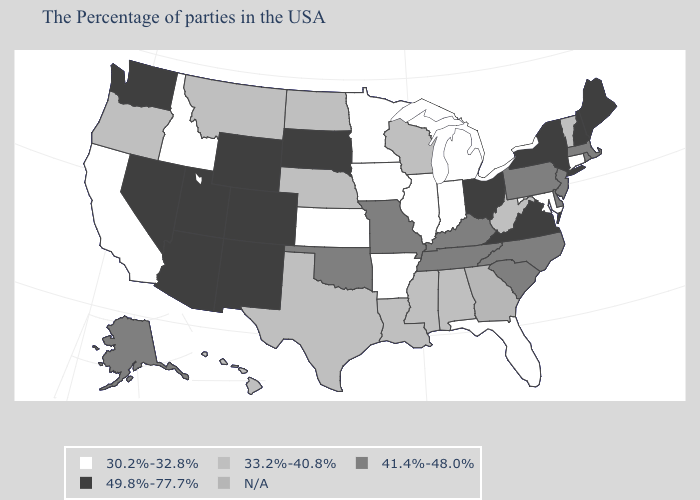What is the value of Pennsylvania?
Short answer required. 41.4%-48.0%. What is the highest value in the USA?
Concise answer only. 49.8%-77.7%. What is the value of Arkansas?
Be succinct. 30.2%-32.8%. Which states have the highest value in the USA?
Short answer required. Maine, New Hampshire, New York, Virginia, Ohio, South Dakota, Wyoming, Colorado, New Mexico, Utah, Arizona, Nevada, Washington. Name the states that have a value in the range 30.2%-32.8%?
Be succinct. Connecticut, Maryland, Florida, Michigan, Indiana, Illinois, Arkansas, Minnesota, Iowa, Kansas, Idaho, California. Among the states that border New Mexico , which have the highest value?
Short answer required. Colorado, Utah, Arizona. Name the states that have a value in the range 49.8%-77.7%?
Concise answer only. Maine, New Hampshire, New York, Virginia, Ohio, South Dakota, Wyoming, Colorado, New Mexico, Utah, Arizona, Nevada, Washington. Name the states that have a value in the range 30.2%-32.8%?
Keep it brief. Connecticut, Maryland, Florida, Michigan, Indiana, Illinois, Arkansas, Minnesota, Iowa, Kansas, Idaho, California. Name the states that have a value in the range N/A?
Concise answer only. Georgia. Among the states that border North Carolina , does Tennessee have the highest value?
Answer briefly. No. Which states hav the highest value in the Northeast?
Answer briefly. Maine, New Hampshire, New York. How many symbols are there in the legend?
Be succinct. 5. How many symbols are there in the legend?
Concise answer only. 5. Does the first symbol in the legend represent the smallest category?
Quick response, please. Yes. 